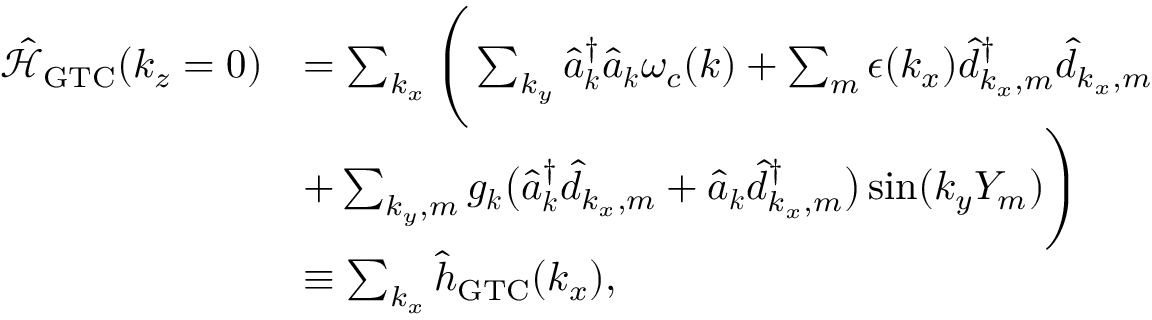Convert formula to latex. <formula><loc_0><loc_0><loc_500><loc_500>\begin{array} { r l } { \mathcal { \hat { H } } _ { G T C } ( k _ { z } = 0 ) } & { = \sum _ { k _ { x } } \left ( \sum _ { k _ { y } } \hat { a } _ { \boldsymbol k } ^ { \dagger } \hat { a } _ { \boldsymbol k } \omega _ { c } ( { \boldsymbol k } ) + \sum _ { m } \epsilon ( k _ { x } ) \hat { d } _ { k _ { x } , m } ^ { \dagger } \hat { d } _ { k _ { x } , m } } \\ & { + \sum _ { { k _ { y } } , m } g _ { \boldsymbol k } \left ( \hat { a } _ { \boldsymbol k } ^ { \dagger } \hat { d } _ { k _ { x } , m } + \hat { a } _ { \boldsymbol k } \hat { d } _ { k _ { x } , m } ^ { \dagger } \right ) \sin ( { k _ { y } } Y _ { m } ) \right ) } \\ & { \equiv \sum _ { k _ { x } } \hat { h } _ { G T C } ( k _ { x } ) , } \end{array}</formula> 